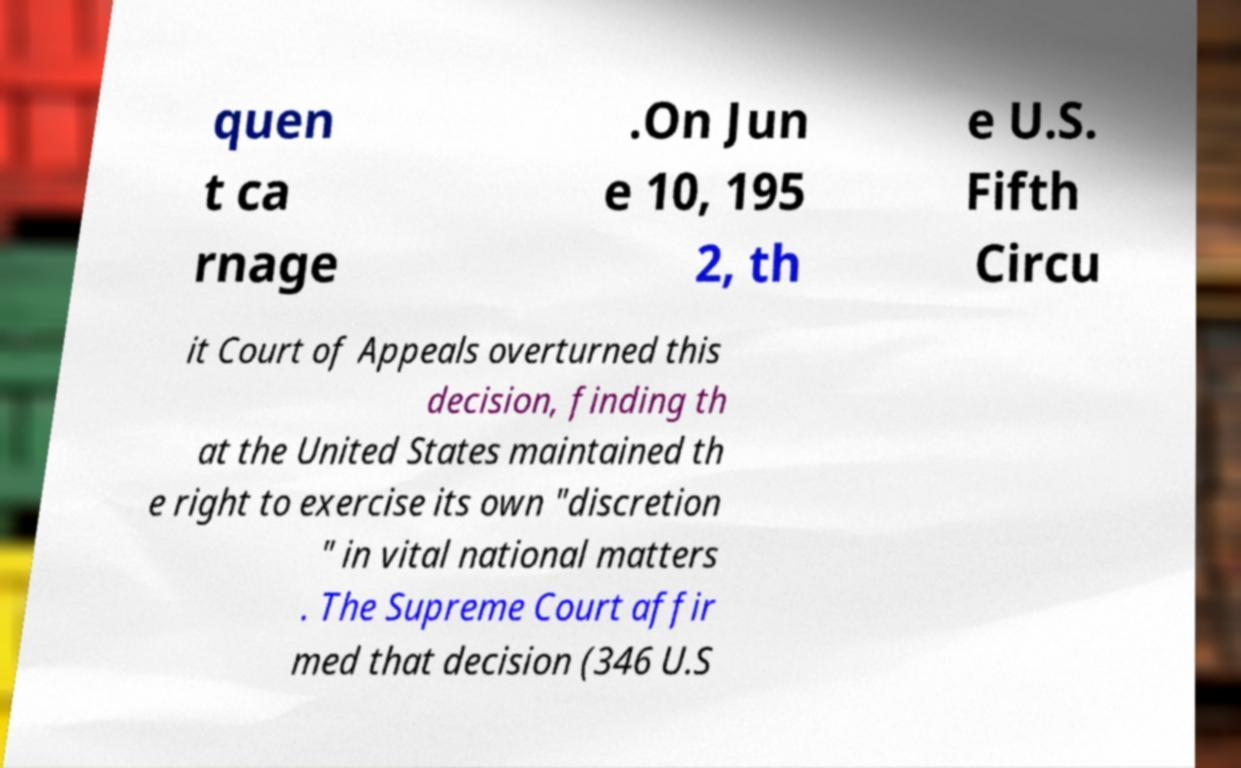What messages or text are displayed in this image? I need them in a readable, typed format. quen t ca rnage .On Jun e 10, 195 2, th e U.S. Fifth Circu it Court of Appeals overturned this decision, finding th at the United States maintained th e right to exercise its own "discretion " in vital national matters . The Supreme Court affir med that decision (346 U.S 